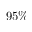Convert formula to latex. <formula><loc_0><loc_0><loc_500><loc_500>9 5 \%</formula> 